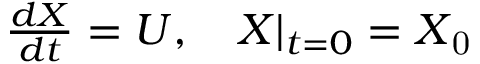<formula> <loc_0><loc_0><loc_500><loc_500>\begin{array} { r } { \frac { d X } { d t } = U , X | _ { t = 0 } = X _ { 0 } } \end{array}</formula> 